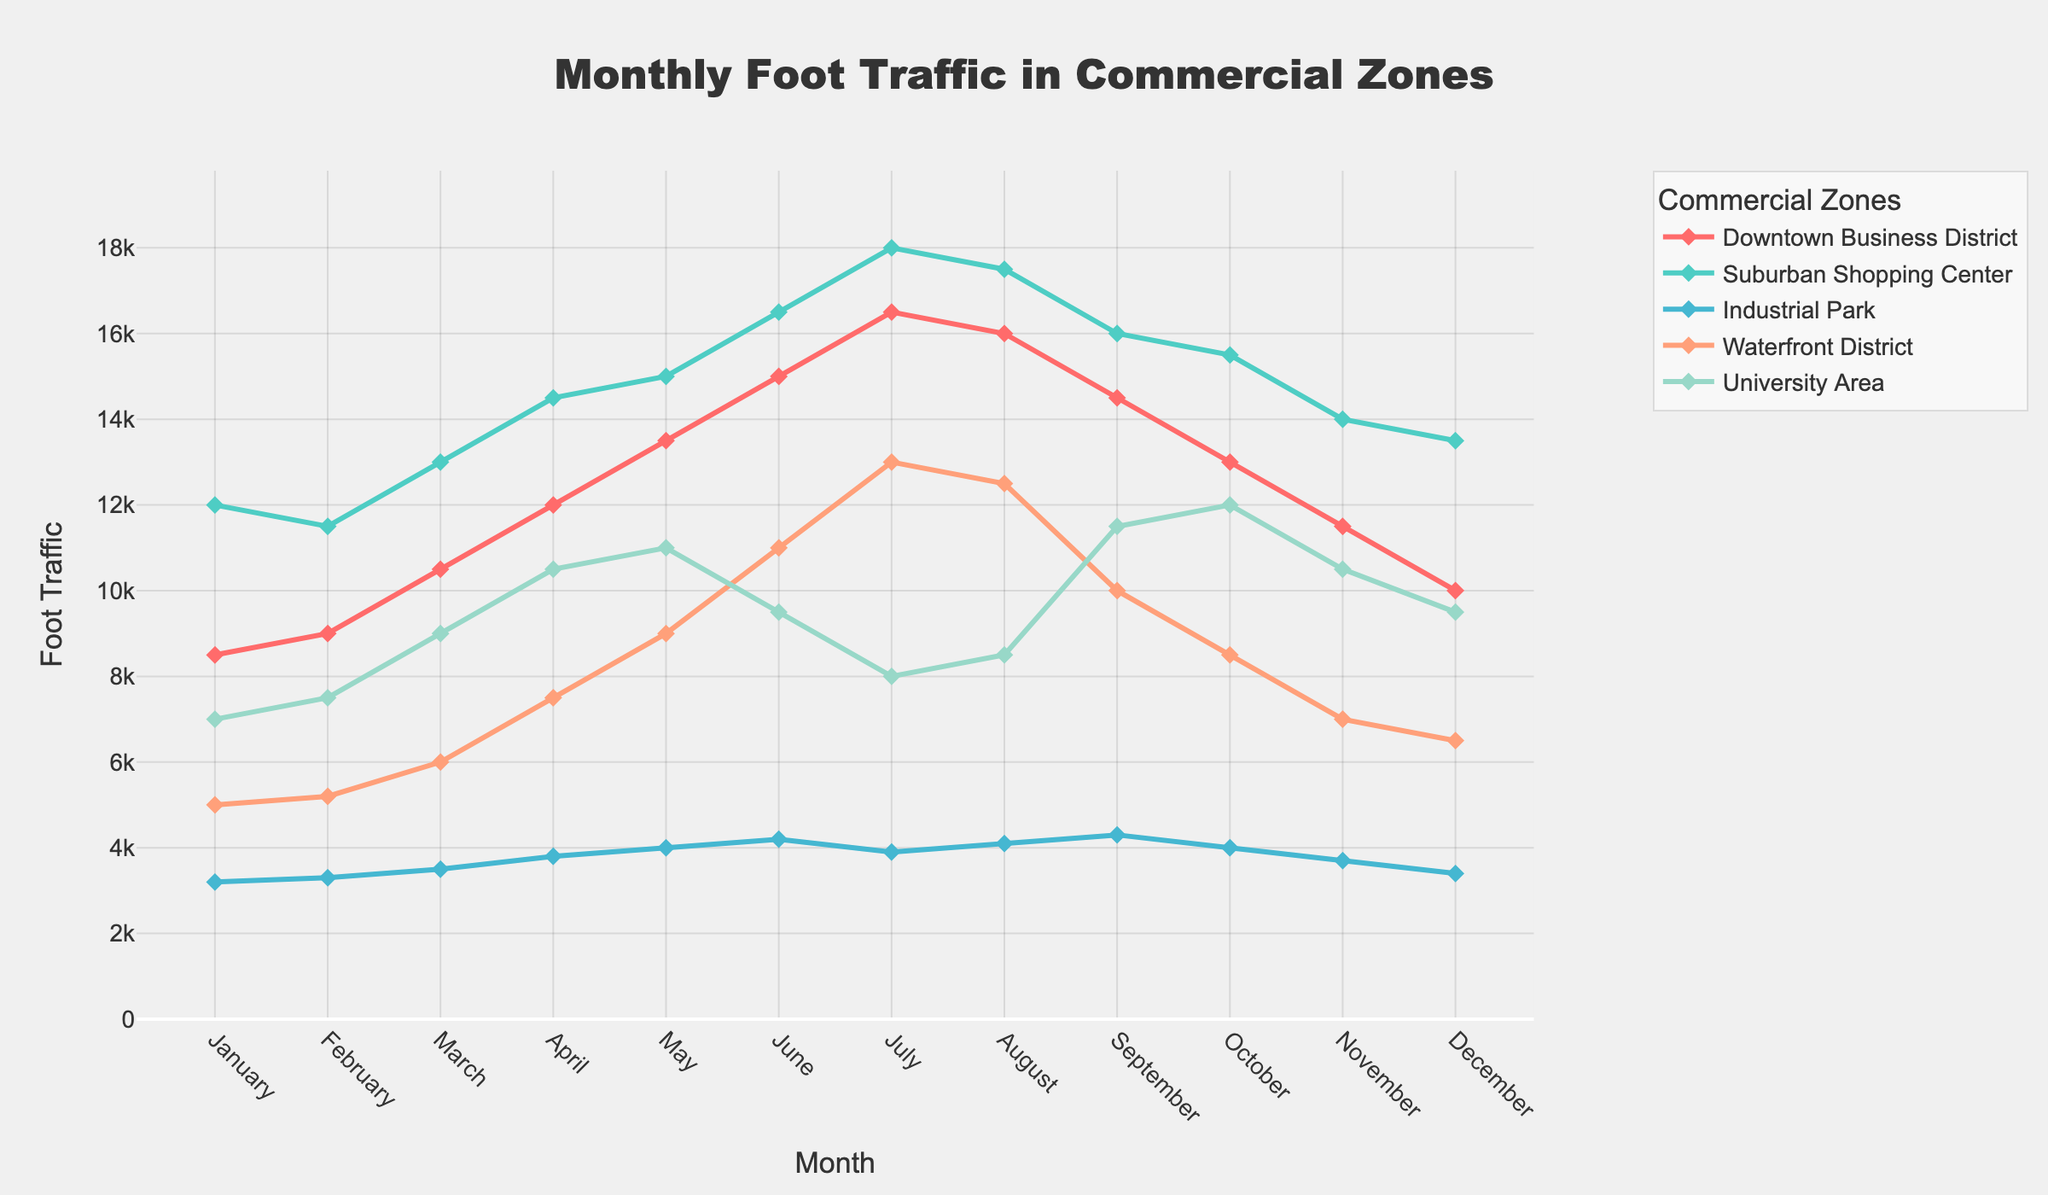What is the highest monthly foot traffic recorded in the Downtown Business District, and in which month? The highest data point in the Downtown Business District line is 16500 in July.
Answer: 16500, July How does the foot traffic in the University Area in November compare to that in October? The University Area has a foot traffic of 10500 in November and 12000 in October. 10500 is less than 12000.
Answer: November < October Which commercial zone has the smallest range of foot traffic throughout the year? The range is calculated by subtracting the minimum value from the maximum value within a zone. The Industrial Park has the smallest range (4300-3200 = 1100).
Answer: Industrial Park Does the foot traffic in any commercial zone peak in the same month that it peaks in another zone? Both Downtown Business District and Suburban Shopping Center peak in July with foot traffics of 16500 and 18000, respectively.
Answer: Yes, Downtown Business District and Suburban Shopping Center in July Calculate the average monthly foot traffic in the Waterfront District. Sum of monthly values: 5000+5200+6000+7500+9000+11000+13000+12500+10000+8500+7000+6500 = 102200. Average: 102200 / 12 = 8516.67.
Answer: 8516.67 By how much does the foot traffic in the Suburban Shopping Center decrease from July to August? In July, the foot traffic is 18000 and in August it is 17500. The decrease is 18000 - 17500 = 500.
Answer: 500 Which month has the lowest foot traffic in the Industrial Park, and what is the foot traffic value? The lowest foot traffic for Industrial Park is in January with 3200.
Answer: January, 3200 Compare the foot traffic difference between May and June for the University Area. May has a traffic of 11000, and June has 9500. The difference is 11000 - 9500 = 1500.
Answer: 1500 What is the foot traffic trend in the Waterfront District from March to July? From March (6000) to July (13000), the foot traffic follows this pattern: 6000 (March), 7500 (April), 9000 (May), 11000 (June), 13000 (July). It shows an increasing trend.
Answer: Increasing trend Calculate the combined foot traffic of all zones in December. Summing up the values for December: 10000 (Downtown Business District) + 13500 (Suburban Shopping Center) + 3400 (Industrial Park) + 6500 (Waterfront District) + 9500 (University Area) = 42900.
Answer: 42900 